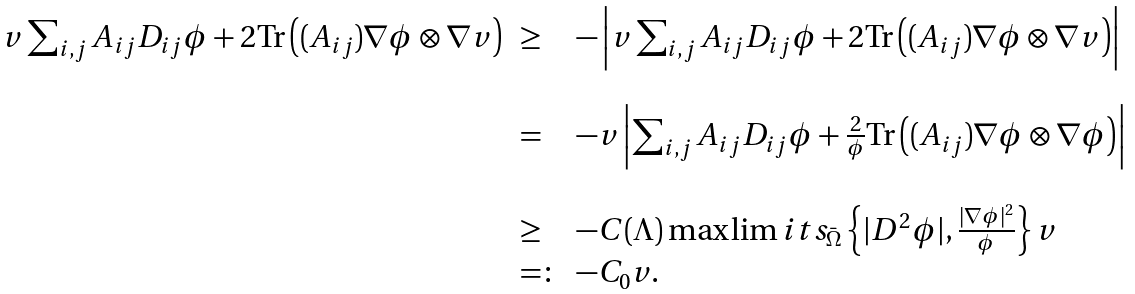<formula> <loc_0><loc_0><loc_500><loc_500>\begin{array} { l l l } v \sum _ { i , j } A _ { i j } D _ { i j } \phi + 2 \text {Tr} \left ( ( A _ { i j } ) \nabla \phi \otimes \nabla v \right ) & \geq & - \left | v \sum _ { i , j } A _ { i j } D _ { i j } \phi + 2 \text {Tr} \left ( ( A _ { i j } ) \nabla \phi \otimes \nabla v \right ) \right | \\ & & \\ & = & - v \left | \sum _ { i , j } A _ { i j } D _ { i j } \phi + \frac { 2 } { \phi } \text {Tr} \left ( ( A _ { i j } ) \nabla \phi \otimes \nabla \phi \right ) \right | \\ & & \\ & \geq & - C ( \Lambda ) \max \lim i t s _ { \bar { \Omega } } \left \{ | D ^ { 2 } \phi | , \frac { | \nabla \phi | ^ { 2 } } { \phi } \right \} v \\ & = \colon & - C _ { 0 } v . \end{array}</formula> 